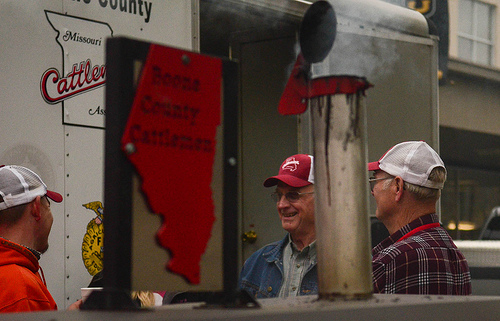<image>
Is there a man behind the truck? No. The man is not behind the truck. From this viewpoint, the man appears to be positioned elsewhere in the scene. 